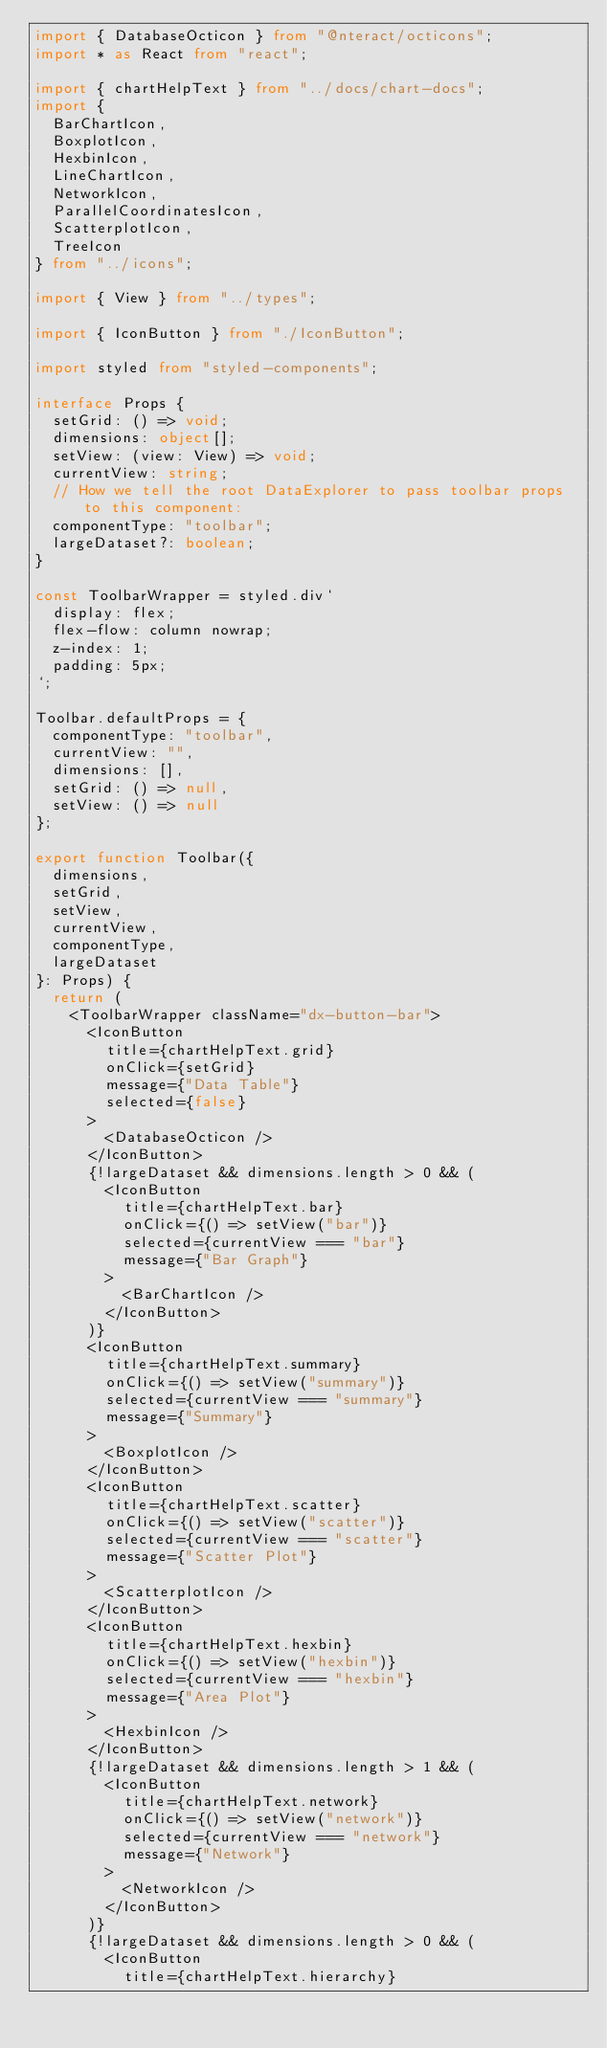Convert code to text. <code><loc_0><loc_0><loc_500><loc_500><_TypeScript_>import { DatabaseOcticon } from "@nteract/octicons";
import * as React from "react";

import { chartHelpText } from "../docs/chart-docs";
import {
  BarChartIcon,
  BoxplotIcon,
  HexbinIcon,
  LineChartIcon,
  NetworkIcon,
  ParallelCoordinatesIcon,
  ScatterplotIcon,
  TreeIcon
} from "../icons";

import { View } from "../types";

import { IconButton } from "./IconButton";

import styled from "styled-components";

interface Props {
  setGrid: () => void;
  dimensions: object[];
  setView: (view: View) => void;
  currentView: string;
  // How we tell the root DataExplorer to pass toolbar props to this component:
  componentType: "toolbar";
  largeDataset?: boolean;
}

const ToolbarWrapper = styled.div`
  display: flex;
  flex-flow: column nowrap;
  z-index: 1;
  padding: 5px;
`;

Toolbar.defaultProps = {
  componentType: "toolbar",
  currentView: "",
  dimensions: [],
  setGrid: () => null,
  setView: () => null
};

export function Toolbar({
  dimensions,
  setGrid,
  setView,
  currentView,
  componentType,
  largeDataset
}: Props) {
  return (
    <ToolbarWrapper className="dx-button-bar">
      <IconButton
        title={chartHelpText.grid}
        onClick={setGrid}
        message={"Data Table"}
        selected={false}
      >
        <DatabaseOcticon />
      </IconButton>
      {!largeDataset && dimensions.length > 0 && (
        <IconButton
          title={chartHelpText.bar}
          onClick={() => setView("bar")}
          selected={currentView === "bar"}
          message={"Bar Graph"}
        >
          <BarChartIcon />
        </IconButton>
      )}
      <IconButton
        title={chartHelpText.summary}
        onClick={() => setView("summary")}
        selected={currentView === "summary"}
        message={"Summary"}
      >
        <BoxplotIcon />
      </IconButton>
      <IconButton
        title={chartHelpText.scatter}
        onClick={() => setView("scatter")}
        selected={currentView === "scatter"}
        message={"Scatter Plot"}
      >
        <ScatterplotIcon />
      </IconButton>
      <IconButton
        title={chartHelpText.hexbin}
        onClick={() => setView("hexbin")}
        selected={currentView === "hexbin"}
        message={"Area Plot"}
      >
        <HexbinIcon />
      </IconButton>
      {!largeDataset && dimensions.length > 1 && (
        <IconButton
          title={chartHelpText.network}
          onClick={() => setView("network")}
          selected={currentView === "network"}
          message={"Network"}
        >
          <NetworkIcon />
        </IconButton>
      )}
      {!largeDataset && dimensions.length > 0 && (
        <IconButton
          title={chartHelpText.hierarchy}</code> 